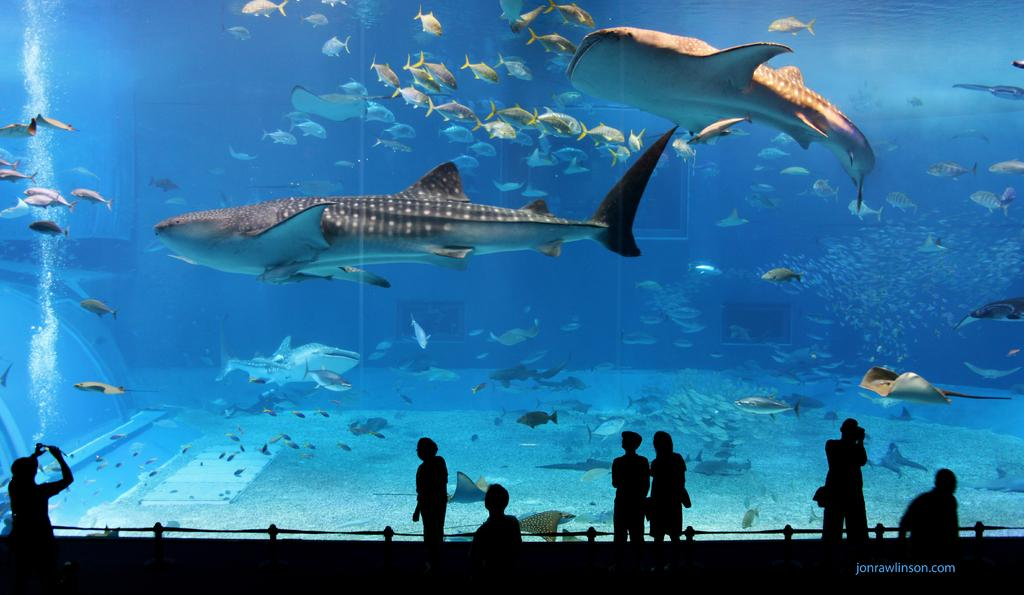What is the main object in the image? There is an aquarium in the image. What is inside the aquarium? The aquarium contains water and fishes. Who or what is present at the bottom of the image? There is a group of people at the bottom of the image. Can you describe any additional features of the image? There is a watermark on the right side bottom of the image. What type of blade can be seen cutting through the water in the image? There is no blade present in the image; it features an aquarium with water and fishes. How does the idea of the aquarium contribute to the heat in the image? The image does not depict any heat or temperature changes, and the concept of the aquarium does not contribute to heat in the image. 